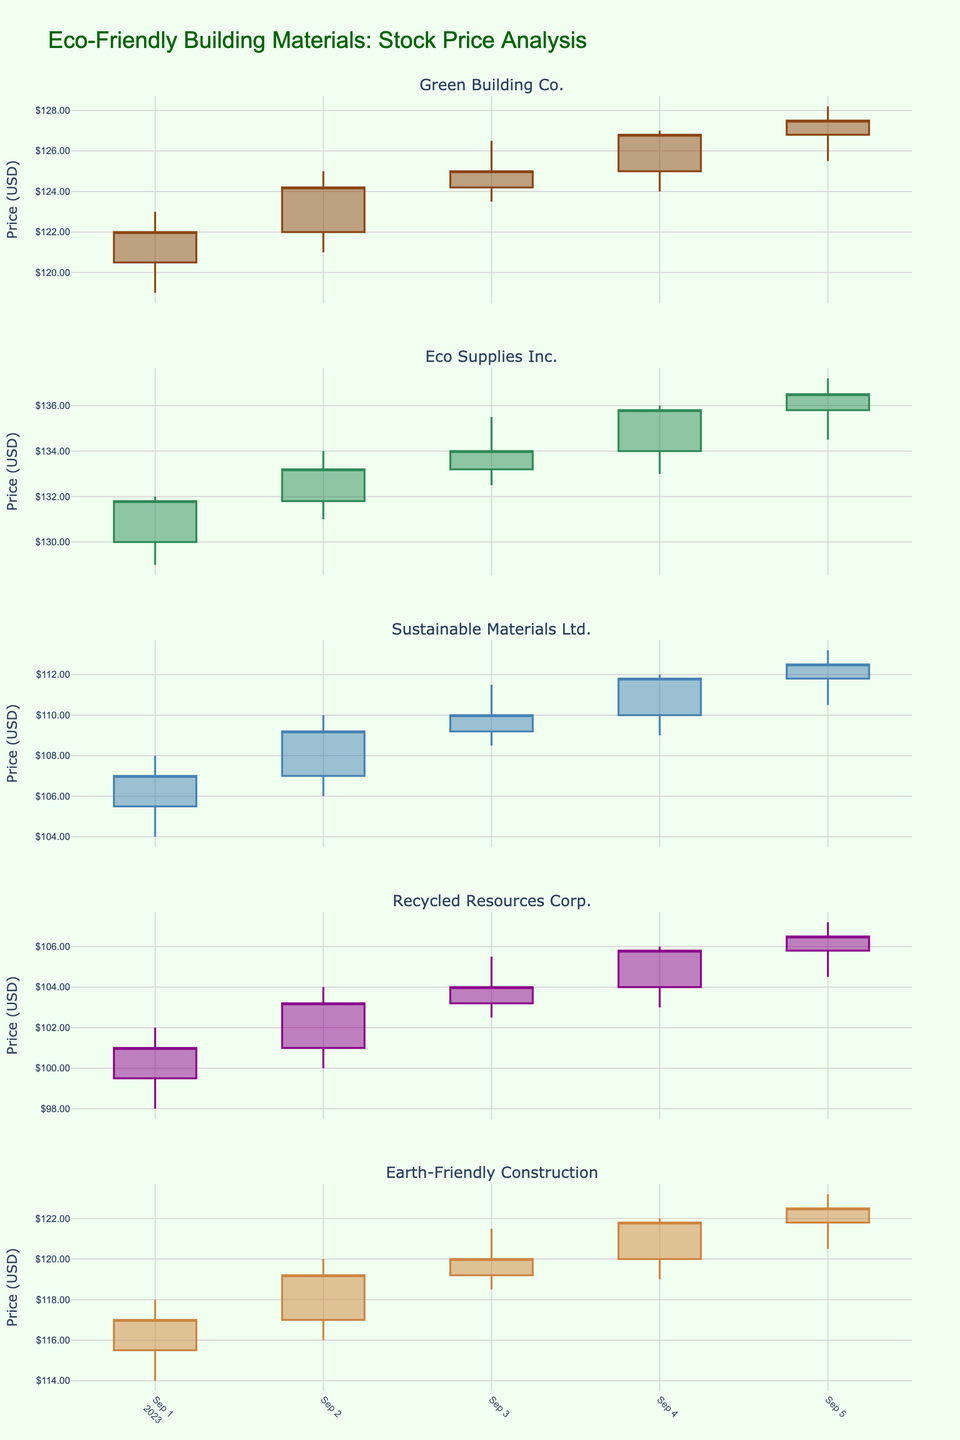What is the title of the plot? The title of the plot is found at the top and provides a summary of what the figure represents.
Answer: Eco-Friendly Building Materials: Stock Price Analysis How many companies are represented in the figure? Count the number of subplot titles or individual candlestick plots, which correspond to different companies.
Answer: 5 Which company had the highest stock price on September 2, 2023? Look at the high values for each company on September 2. Compare them to find the highest one.
Answer: Eco Supplies Inc What is the closing price of Earth-Friendly Construction on September 4, 2023? Locate the candlestick for Earth-Friendly Construction on September 4 and read the closing price.
Answer: 121.8 Between September 1 and September 5, which company's stock price showed the most increase in closing value? Calculate the difference in closing prices on September 1 and September 5 for each company and find the one with the highest positive change.
Answer: Recycled Resources Corp What color represents the increasing stocks for Sustainable Materials Ltd.? Identify the color of the candlestick increasing line for Sustainable Materials Ltd. in the legend or plot.
Answer: Blue (a shade of blue) Which company had the smallest fluctuation in stock prices on September 3, 2023? Evaluate the range (high - low) for each company on September 3 and find the company with the smallest range.
Answer: Recycled Resources Corp What is the average closing price for Green Building Co. over the five days? Sum the closing prices for Green Building Co. over five days and divide by the number of days. (122.0 + 124.2 + 125.0 + 126.8 + 127.5) / 5
Answer: 125.1 Did any company's stock price decrease over the days displayed? If so, which one? Compare the opening and closing prices over the period for each company. Look for any company where the closing price on the last day is lower than the opening price on the first day. None of the companies show a decrease in closing price over the displayed days.
Answer: None 